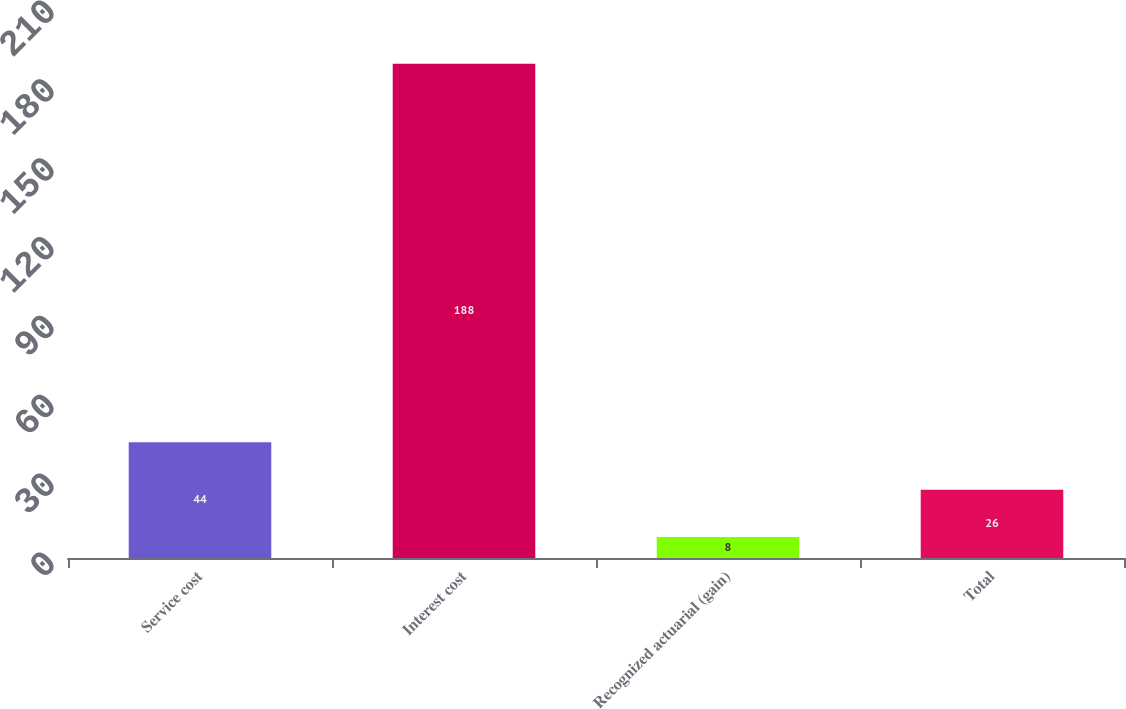<chart> <loc_0><loc_0><loc_500><loc_500><bar_chart><fcel>Service cost<fcel>Interest cost<fcel>Recognized actuarial (gain)<fcel>Total<nl><fcel>44<fcel>188<fcel>8<fcel>26<nl></chart> 